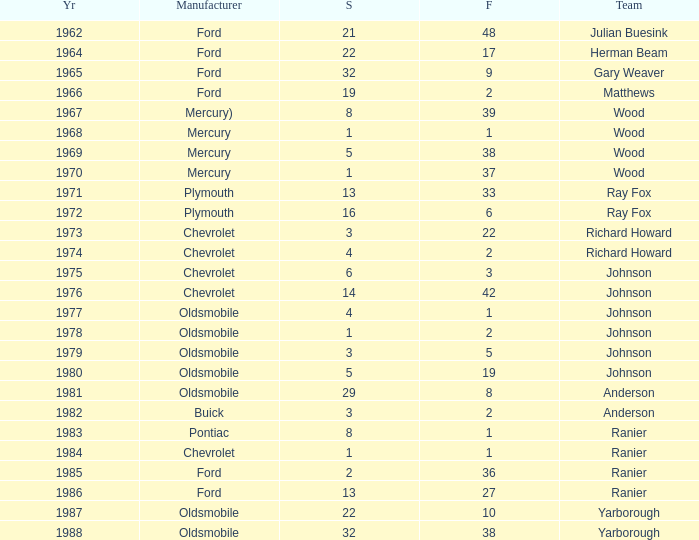What is the smallest finish time for a race after 1972 with a car manufactured by pontiac? 1.0. 